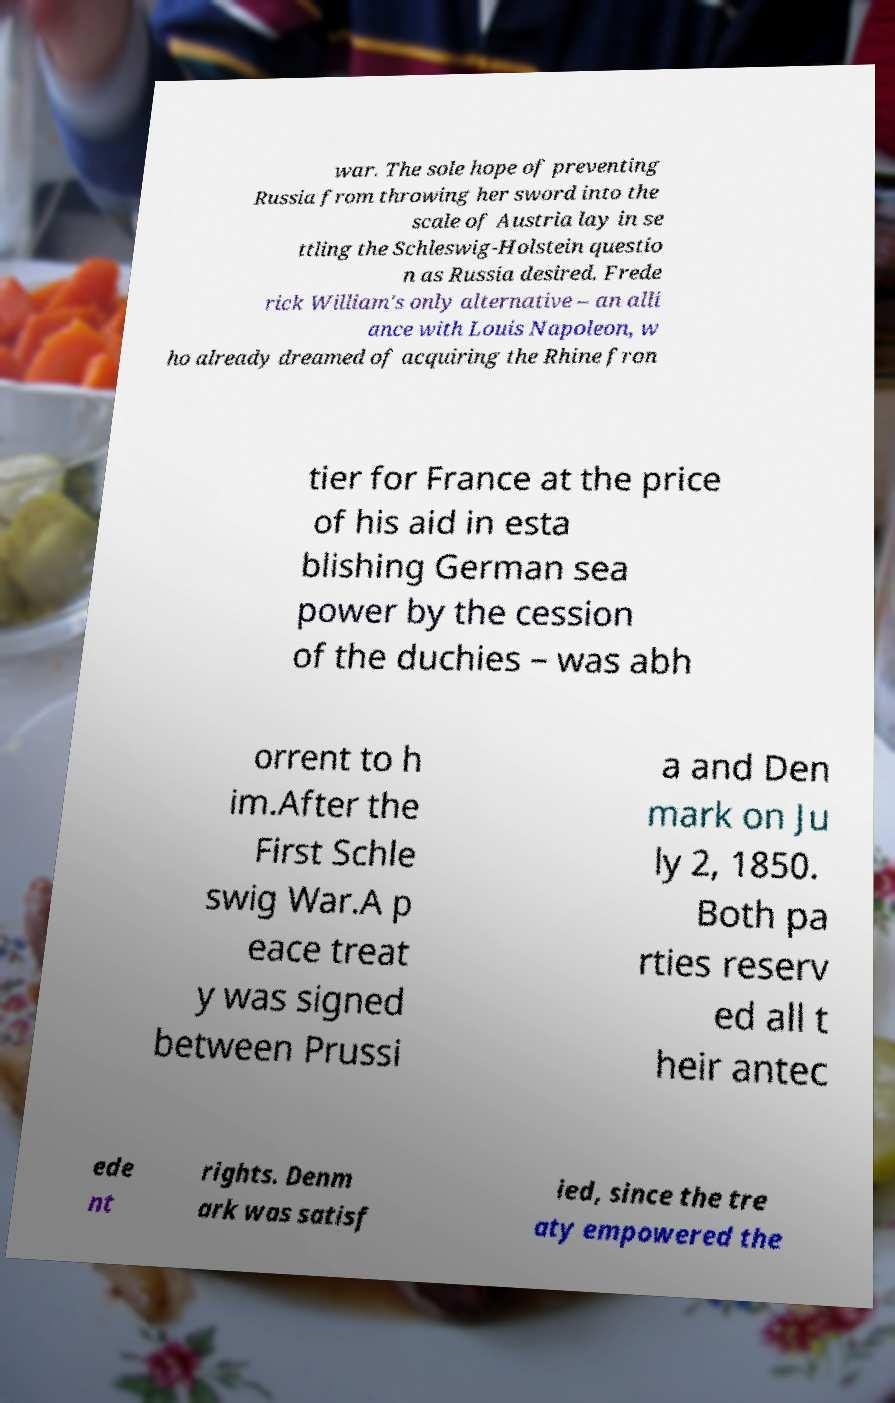There's text embedded in this image that I need extracted. Can you transcribe it verbatim? war. The sole hope of preventing Russia from throwing her sword into the scale of Austria lay in se ttling the Schleswig-Holstein questio n as Russia desired. Frede rick William's only alternative – an alli ance with Louis Napoleon, w ho already dreamed of acquiring the Rhine fron tier for France at the price of his aid in esta blishing German sea power by the cession of the duchies – was abh orrent to h im.After the First Schle swig War.A p eace treat y was signed between Prussi a and Den mark on Ju ly 2, 1850. Both pa rties reserv ed all t heir antec ede nt rights. Denm ark was satisf ied, since the tre aty empowered the 